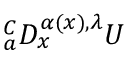<formula> <loc_0><loc_0><loc_500><loc_500>{ } _ { a } ^ { C } D _ { x } ^ { \alpha ( x ) , \lambda } U</formula> 